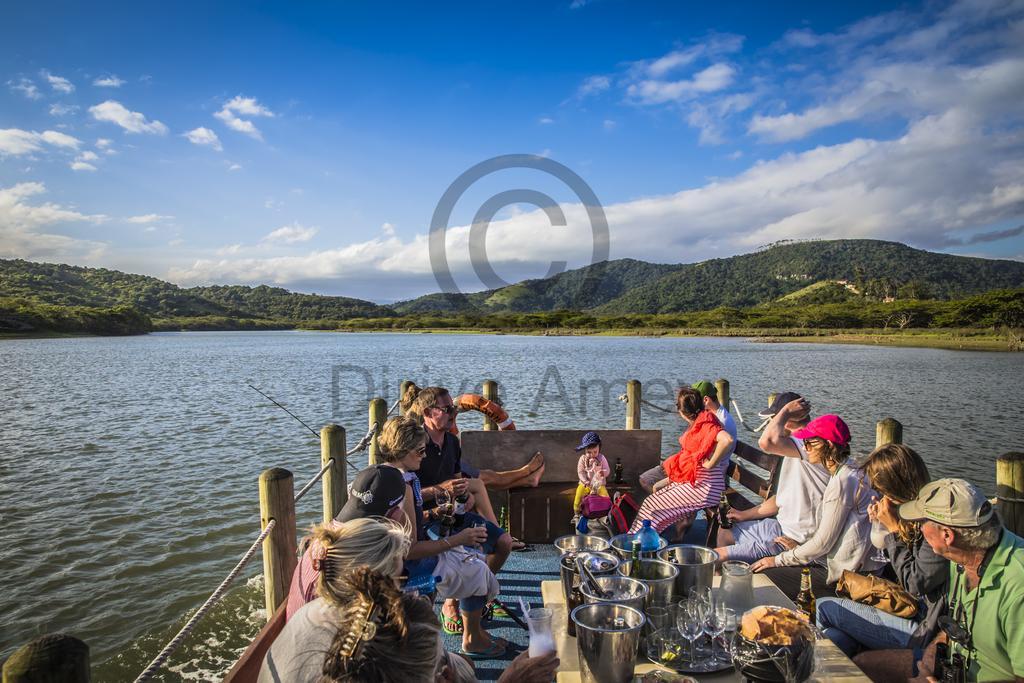How would you summarize this image in a sentence or two? In the image in the center, we can see one boat. In the boat, we can see a few people are sitting around the table. On the table, we can see containers, glasses, bottles and a few other objects. In the background we can see the sky, clouds, trees, hills, water and watermark. 